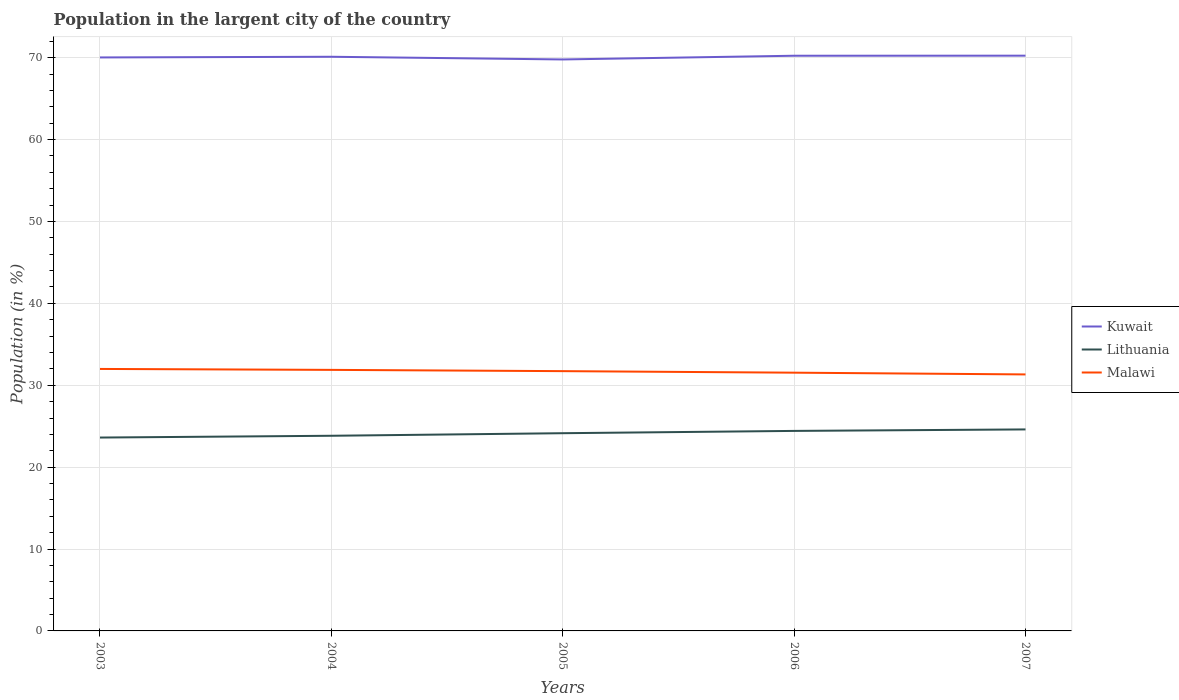Does the line corresponding to Malawi intersect with the line corresponding to Lithuania?
Provide a succinct answer. No. Is the number of lines equal to the number of legend labels?
Ensure brevity in your answer.  Yes. Across all years, what is the maximum percentage of population in the largent city in Kuwait?
Your answer should be very brief. 69.79. In which year was the percentage of population in the largent city in Malawi maximum?
Your response must be concise. 2007. What is the total percentage of population in the largent city in Malawi in the graph?
Your response must be concise. 0.56. What is the difference between the highest and the second highest percentage of population in the largent city in Lithuania?
Make the answer very short. 0.99. What is the difference between the highest and the lowest percentage of population in the largent city in Lithuania?
Offer a very short reply. 3. Is the percentage of population in the largent city in Malawi strictly greater than the percentage of population in the largent city in Kuwait over the years?
Offer a very short reply. Yes. How many years are there in the graph?
Provide a short and direct response. 5. Does the graph contain grids?
Give a very brief answer. Yes. What is the title of the graph?
Your answer should be compact. Population in the largent city of the country. What is the label or title of the Y-axis?
Keep it short and to the point. Population (in %). What is the Population (in %) of Kuwait in 2003?
Offer a very short reply. 70.03. What is the Population (in %) in Lithuania in 2003?
Your answer should be very brief. 23.61. What is the Population (in %) in Malawi in 2003?
Your response must be concise. 31.99. What is the Population (in %) in Kuwait in 2004?
Offer a very short reply. 70.11. What is the Population (in %) of Lithuania in 2004?
Your response must be concise. 23.83. What is the Population (in %) of Malawi in 2004?
Offer a very short reply. 31.88. What is the Population (in %) of Kuwait in 2005?
Give a very brief answer. 69.79. What is the Population (in %) of Lithuania in 2005?
Offer a very short reply. 24.15. What is the Population (in %) in Malawi in 2005?
Your answer should be very brief. 31.72. What is the Population (in %) of Kuwait in 2006?
Give a very brief answer. 70.24. What is the Population (in %) in Lithuania in 2006?
Your response must be concise. 24.42. What is the Population (in %) of Malawi in 2006?
Provide a short and direct response. 31.54. What is the Population (in %) in Kuwait in 2007?
Ensure brevity in your answer.  70.25. What is the Population (in %) in Lithuania in 2007?
Keep it short and to the point. 24.61. What is the Population (in %) of Malawi in 2007?
Your response must be concise. 31.32. Across all years, what is the maximum Population (in %) in Kuwait?
Make the answer very short. 70.25. Across all years, what is the maximum Population (in %) in Lithuania?
Provide a succinct answer. 24.61. Across all years, what is the maximum Population (in %) of Malawi?
Your answer should be very brief. 31.99. Across all years, what is the minimum Population (in %) in Kuwait?
Provide a short and direct response. 69.79. Across all years, what is the minimum Population (in %) of Lithuania?
Your answer should be compact. 23.61. Across all years, what is the minimum Population (in %) of Malawi?
Offer a very short reply. 31.32. What is the total Population (in %) in Kuwait in the graph?
Give a very brief answer. 350.42. What is the total Population (in %) of Lithuania in the graph?
Your answer should be compact. 120.62. What is the total Population (in %) in Malawi in the graph?
Your response must be concise. 158.45. What is the difference between the Population (in %) of Kuwait in 2003 and that in 2004?
Ensure brevity in your answer.  -0.08. What is the difference between the Population (in %) in Lithuania in 2003 and that in 2004?
Offer a terse response. -0.22. What is the difference between the Population (in %) of Malawi in 2003 and that in 2004?
Offer a terse response. 0.11. What is the difference between the Population (in %) of Kuwait in 2003 and that in 2005?
Keep it short and to the point. 0.25. What is the difference between the Population (in %) in Lithuania in 2003 and that in 2005?
Your answer should be very brief. -0.53. What is the difference between the Population (in %) of Malawi in 2003 and that in 2005?
Ensure brevity in your answer.  0.27. What is the difference between the Population (in %) in Kuwait in 2003 and that in 2006?
Make the answer very short. -0.21. What is the difference between the Population (in %) of Lithuania in 2003 and that in 2006?
Your answer should be very brief. -0.81. What is the difference between the Population (in %) of Malawi in 2003 and that in 2006?
Provide a short and direct response. 0.46. What is the difference between the Population (in %) in Kuwait in 2003 and that in 2007?
Ensure brevity in your answer.  -0.22. What is the difference between the Population (in %) of Lithuania in 2003 and that in 2007?
Make the answer very short. -0.99. What is the difference between the Population (in %) in Malawi in 2003 and that in 2007?
Offer a very short reply. 0.67. What is the difference between the Population (in %) of Kuwait in 2004 and that in 2005?
Make the answer very short. 0.33. What is the difference between the Population (in %) of Lithuania in 2004 and that in 2005?
Your answer should be very brief. -0.31. What is the difference between the Population (in %) in Malawi in 2004 and that in 2005?
Offer a terse response. 0.15. What is the difference between the Population (in %) in Kuwait in 2004 and that in 2006?
Provide a succinct answer. -0.13. What is the difference between the Population (in %) of Lithuania in 2004 and that in 2006?
Make the answer very short. -0.59. What is the difference between the Population (in %) of Malawi in 2004 and that in 2006?
Your answer should be very brief. 0.34. What is the difference between the Population (in %) in Kuwait in 2004 and that in 2007?
Offer a very short reply. -0.13. What is the difference between the Population (in %) in Lithuania in 2004 and that in 2007?
Your answer should be compact. -0.78. What is the difference between the Population (in %) in Malawi in 2004 and that in 2007?
Give a very brief answer. 0.56. What is the difference between the Population (in %) of Kuwait in 2005 and that in 2006?
Offer a terse response. -0.46. What is the difference between the Population (in %) in Lithuania in 2005 and that in 2006?
Your answer should be very brief. -0.28. What is the difference between the Population (in %) of Malawi in 2005 and that in 2006?
Give a very brief answer. 0.19. What is the difference between the Population (in %) of Kuwait in 2005 and that in 2007?
Ensure brevity in your answer.  -0.46. What is the difference between the Population (in %) in Lithuania in 2005 and that in 2007?
Keep it short and to the point. -0.46. What is the difference between the Population (in %) of Malawi in 2005 and that in 2007?
Keep it short and to the point. 0.4. What is the difference between the Population (in %) in Kuwait in 2006 and that in 2007?
Make the answer very short. -0.01. What is the difference between the Population (in %) of Lithuania in 2006 and that in 2007?
Keep it short and to the point. -0.18. What is the difference between the Population (in %) in Malawi in 2006 and that in 2007?
Offer a terse response. 0.21. What is the difference between the Population (in %) of Kuwait in 2003 and the Population (in %) of Lithuania in 2004?
Make the answer very short. 46.2. What is the difference between the Population (in %) of Kuwait in 2003 and the Population (in %) of Malawi in 2004?
Your response must be concise. 38.15. What is the difference between the Population (in %) in Lithuania in 2003 and the Population (in %) in Malawi in 2004?
Keep it short and to the point. -8.26. What is the difference between the Population (in %) in Kuwait in 2003 and the Population (in %) in Lithuania in 2005?
Your answer should be very brief. 45.89. What is the difference between the Population (in %) of Kuwait in 2003 and the Population (in %) of Malawi in 2005?
Keep it short and to the point. 38.31. What is the difference between the Population (in %) in Lithuania in 2003 and the Population (in %) in Malawi in 2005?
Your answer should be compact. -8.11. What is the difference between the Population (in %) in Kuwait in 2003 and the Population (in %) in Lithuania in 2006?
Provide a succinct answer. 45.61. What is the difference between the Population (in %) of Kuwait in 2003 and the Population (in %) of Malawi in 2006?
Offer a very short reply. 38.5. What is the difference between the Population (in %) in Lithuania in 2003 and the Population (in %) in Malawi in 2006?
Your response must be concise. -7.92. What is the difference between the Population (in %) in Kuwait in 2003 and the Population (in %) in Lithuania in 2007?
Make the answer very short. 45.43. What is the difference between the Population (in %) of Kuwait in 2003 and the Population (in %) of Malawi in 2007?
Keep it short and to the point. 38.71. What is the difference between the Population (in %) in Lithuania in 2003 and the Population (in %) in Malawi in 2007?
Your response must be concise. -7.71. What is the difference between the Population (in %) of Kuwait in 2004 and the Population (in %) of Lithuania in 2005?
Offer a terse response. 45.97. What is the difference between the Population (in %) in Kuwait in 2004 and the Population (in %) in Malawi in 2005?
Provide a short and direct response. 38.39. What is the difference between the Population (in %) of Lithuania in 2004 and the Population (in %) of Malawi in 2005?
Your answer should be very brief. -7.89. What is the difference between the Population (in %) of Kuwait in 2004 and the Population (in %) of Lithuania in 2006?
Offer a very short reply. 45.69. What is the difference between the Population (in %) of Kuwait in 2004 and the Population (in %) of Malawi in 2006?
Your response must be concise. 38.58. What is the difference between the Population (in %) of Lithuania in 2004 and the Population (in %) of Malawi in 2006?
Provide a succinct answer. -7.7. What is the difference between the Population (in %) in Kuwait in 2004 and the Population (in %) in Lithuania in 2007?
Your response must be concise. 45.51. What is the difference between the Population (in %) in Kuwait in 2004 and the Population (in %) in Malawi in 2007?
Give a very brief answer. 38.79. What is the difference between the Population (in %) of Lithuania in 2004 and the Population (in %) of Malawi in 2007?
Provide a short and direct response. -7.49. What is the difference between the Population (in %) in Kuwait in 2005 and the Population (in %) in Lithuania in 2006?
Offer a very short reply. 45.36. What is the difference between the Population (in %) in Kuwait in 2005 and the Population (in %) in Malawi in 2006?
Ensure brevity in your answer.  38.25. What is the difference between the Population (in %) in Lithuania in 2005 and the Population (in %) in Malawi in 2006?
Your response must be concise. -7.39. What is the difference between the Population (in %) of Kuwait in 2005 and the Population (in %) of Lithuania in 2007?
Make the answer very short. 45.18. What is the difference between the Population (in %) in Kuwait in 2005 and the Population (in %) in Malawi in 2007?
Ensure brevity in your answer.  38.46. What is the difference between the Population (in %) in Lithuania in 2005 and the Population (in %) in Malawi in 2007?
Your answer should be very brief. -7.18. What is the difference between the Population (in %) of Kuwait in 2006 and the Population (in %) of Lithuania in 2007?
Offer a very short reply. 45.63. What is the difference between the Population (in %) of Kuwait in 2006 and the Population (in %) of Malawi in 2007?
Provide a succinct answer. 38.92. What is the difference between the Population (in %) of Lithuania in 2006 and the Population (in %) of Malawi in 2007?
Your answer should be compact. -6.9. What is the average Population (in %) in Kuwait per year?
Your answer should be compact. 70.08. What is the average Population (in %) of Lithuania per year?
Your answer should be compact. 24.12. What is the average Population (in %) of Malawi per year?
Make the answer very short. 31.69. In the year 2003, what is the difference between the Population (in %) in Kuwait and Population (in %) in Lithuania?
Make the answer very short. 46.42. In the year 2003, what is the difference between the Population (in %) of Kuwait and Population (in %) of Malawi?
Keep it short and to the point. 38.04. In the year 2003, what is the difference between the Population (in %) of Lithuania and Population (in %) of Malawi?
Offer a very short reply. -8.38. In the year 2004, what is the difference between the Population (in %) of Kuwait and Population (in %) of Lithuania?
Provide a succinct answer. 46.28. In the year 2004, what is the difference between the Population (in %) of Kuwait and Population (in %) of Malawi?
Your answer should be very brief. 38.24. In the year 2004, what is the difference between the Population (in %) of Lithuania and Population (in %) of Malawi?
Offer a terse response. -8.05. In the year 2005, what is the difference between the Population (in %) in Kuwait and Population (in %) in Lithuania?
Keep it short and to the point. 45.64. In the year 2005, what is the difference between the Population (in %) in Kuwait and Population (in %) in Malawi?
Your answer should be compact. 38.06. In the year 2005, what is the difference between the Population (in %) in Lithuania and Population (in %) in Malawi?
Offer a very short reply. -7.58. In the year 2006, what is the difference between the Population (in %) in Kuwait and Population (in %) in Lithuania?
Make the answer very short. 45.82. In the year 2006, what is the difference between the Population (in %) of Kuwait and Population (in %) of Malawi?
Your answer should be compact. 38.7. In the year 2006, what is the difference between the Population (in %) of Lithuania and Population (in %) of Malawi?
Provide a succinct answer. -7.11. In the year 2007, what is the difference between the Population (in %) in Kuwait and Population (in %) in Lithuania?
Give a very brief answer. 45.64. In the year 2007, what is the difference between the Population (in %) in Kuwait and Population (in %) in Malawi?
Keep it short and to the point. 38.93. In the year 2007, what is the difference between the Population (in %) in Lithuania and Population (in %) in Malawi?
Provide a short and direct response. -6.72. What is the ratio of the Population (in %) of Lithuania in 2003 to that in 2004?
Keep it short and to the point. 0.99. What is the ratio of the Population (in %) in Malawi in 2003 to that in 2004?
Provide a succinct answer. 1. What is the ratio of the Population (in %) in Kuwait in 2003 to that in 2005?
Ensure brevity in your answer.  1. What is the ratio of the Population (in %) in Lithuania in 2003 to that in 2005?
Provide a succinct answer. 0.98. What is the ratio of the Population (in %) in Malawi in 2003 to that in 2005?
Provide a succinct answer. 1.01. What is the ratio of the Population (in %) of Kuwait in 2003 to that in 2006?
Your response must be concise. 1. What is the ratio of the Population (in %) in Lithuania in 2003 to that in 2006?
Keep it short and to the point. 0.97. What is the ratio of the Population (in %) of Malawi in 2003 to that in 2006?
Offer a terse response. 1.01. What is the ratio of the Population (in %) of Kuwait in 2003 to that in 2007?
Provide a short and direct response. 1. What is the ratio of the Population (in %) of Lithuania in 2003 to that in 2007?
Keep it short and to the point. 0.96. What is the ratio of the Population (in %) of Malawi in 2003 to that in 2007?
Your response must be concise. 1.02. What is the ratio of the Population (in %) of Kuwait in 2004 to that in 2005?
Provide a short and direct response. 1. What is the ratio of the Population (in %) of Lithuania in 2004 to that in 2005?
Your response must be concise. 0.99. What is the ratio of the Population (in %) in Malawi in 2004 to that in 2005?
Your answer should be very brief. 1. What is the ratio of the Population (in %) in Lithuania in 2004 to that in 2006?
Provide a succinct answer. 0.98. What is the ratio of the Population (in %) of Malawi in 2004 to that in 2006?
Offer a very short reply. 1.01. What is the ratio of the Population (in %) of Lithuania in 2004 to that in 2007?
Ensure brevity in your answer.  0.97. What is the ratio of the Population (in %) in Malawi in 2004 to that in 2007?
Give a very brief answer. 1.02. What is the ratio of the Population (in %) in Kuwait in 2005 to that in 2006?
Your answer should be very brief. 0.99. What is the ratio of the Population (in %) in Lithuania in 2005 to that in 2006?
Ensure brevity in your answer.  0.99. What is the ratio of the Population (in %) in Malawi in 2005 to that in 2006?
Offer a very short reply. 1.01. What is the ratio of the Population (in %) in Lithuania in 2005 to that in 2007?
Provide a succinct answer. 0.98. What is the ratio of the Population (in %) of Malawi in 2005 to that in 2007?
Make the answer very short. 1.01. What is the ratio of the Population (in %) in Kuwait in 2006 to that in 2007?
Your answer should be compact. 1. What is the ratio of the Population (in %) in Malawi in 2006 to that in 2007?
Your answer should be very brief. 1.01. What is the difference between the highest and the second highest Population (in %) of Kuwait?
Your answer should be very brief. 0.01. What is the difference between the highest and the second highest Population (in %) of Lithuania?
Ensure brevity in your answer.  0.18. What is the difference between the highest and the second highest Population (in %) in Malawi?
Provide a succinct answer. 0.11. What is the difference between the highest and the lowest Population (in %) of Kuwait?
Offer a terse response. 0.46. What is the difference between the highest and the lowest Population (in %) in Malawi?
Ensure brevity in your answer.  0.67. 